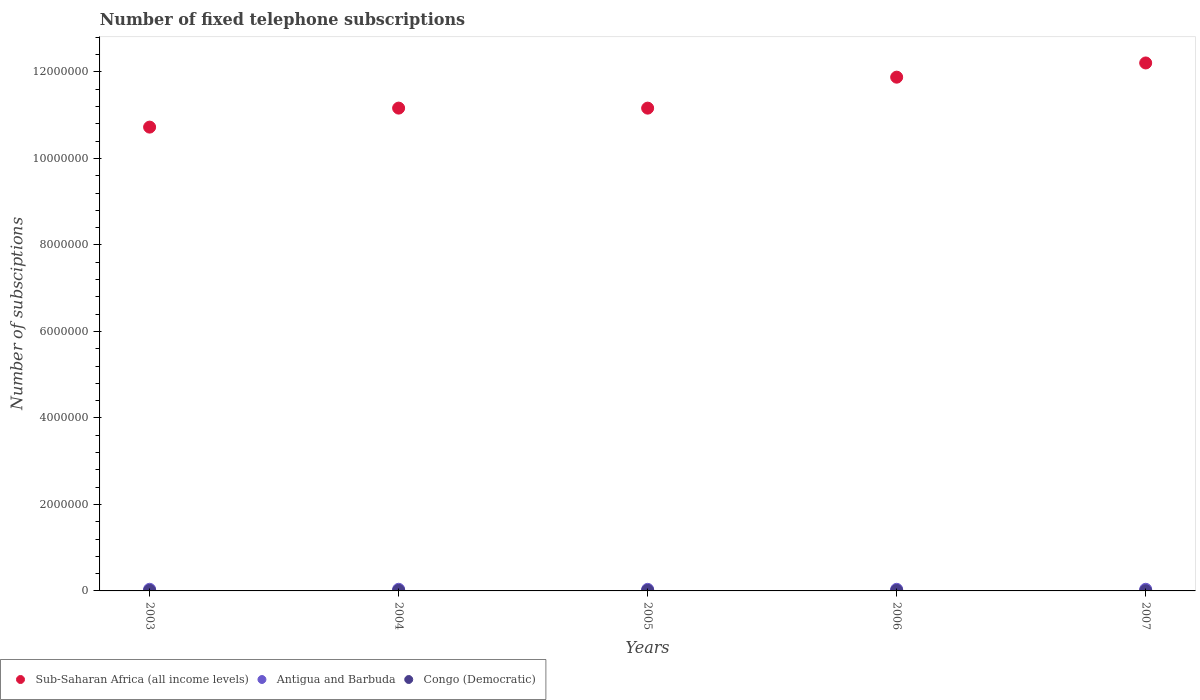How many different coloured dotlines are there?
Keep it short and to the point. 3. What is the number of fixed telephone subscriptions in Sub-Saharan Africa (all income levels) in 2006?
Keep it short and to the point. 1.19e+07. Across all years, what is the maximum number of fixed telephone subscriptions in Antigua and Barbuda?
Provide a short and direct response. 3.80e+04. Across all years, what is the minimum number of fixed telephone subscriptions in Congo (Democratic)?
Give a very brief answer. 3500. In which year was the number of fixed telephone subscriptions in Antigua and Barbuda maximum?
Give a very brief answer. 2003. In which year was the number of fixed telephone subscriptions in Antigua and Barbuda minimum?
Provide a short and direct response. 2005. What is the total number of fixed telephone subscriptions in Antigua and Barbuda in the graph?
Ensure brevity in your answer.  1.88e+05. What is the difference between the number of fixed telephone subscriptions in Antigua and Barbuda in 2006 and the number of fixed telephone subscriptions in Congo (Democratic) in 2007?
Your answer should be compact. 3.40e+04. What is the average number of fixed telephone subscriptions in Sub-Saharan Africa (all income levels) per year?
Make the answer very short. 1.14e+07. In the year 2006, what is the difference between the number of fixed telephone subscriptions in Antigua and Barbuda and number of fixed telephone subscriptions in Congo (Democratic)?
Your answer should be very brief. 2.78e+04. In how many years, is the number of fixed telephone subscriptions in Congo (Democratic) greater than 3200000?
Provide a succinct answer. 0. What is the ratio of the number of fixed telephone subscriptions in Sub-Saharan Africa (all income levels) in 2003 to that in 2005?
Ensure brevity in your answer.  0.96. Is the difference between the number of fixed telephone subscriptions in Antigua and Barbuda in 2004 and 2005 greater than the difference between the number of fixed telephone subscriptions in Congo (Democratic) in 2004 and 2005?
Offer a very short reply. Yes. What is the difference between the highest and the lowest number of fixed telephone subscriptions in Antigua and Barbuda?
Give a very brief answer. 1520. In how many years, is the number of fixed telephone subscriptions in Antigua and Barbuda greater than the average number of fixed telephone subscriptions in Antigua and Barbuda taken over all years?
Your answer should be very brief. 3. Does the number of fixed telephone subscriptions in Sub-Saharan Africa (all income levels) monotonically increase over the years?
Provide a succinct answer. No. Is the number of fixed telephone subscriptions in Sub-Saharan Africa (all income levels) strictly greater than the number of fixed telephone subscriptions in Antigua and Barbuda over the years?
Make the answer very short. Yes. How many dotlines are there?
Your response must be concise. 3. Are the values on the major ticks of Y-axis written in scientific E-notation?
Your answer should be compact. No. Does the graph contain any zero values?
Provide a succinct answer. No. Where does the legend appear in the graph?
Your answer should be very brief. Bottom left. How are the legend labels stacked?
Your answer should be compact. Horizontal. What is the title of the graph?
Provide a succinct answer. Number of fixed telephone subscriptions. Does "United Kingdom" appear as one of the legend labels in the graph?
Give a very brief answer. No. What is the label or title of the Y-axis?
Ensure brevity in your answer.  Number of subsciptions. What is the Number of subsciptions in Sub-Saharan Africa (all income levels) in 2003?
Provide a succinct answer. 1.07e+07. What is the Number of subsciptions of Antigua and Barbuda in 2003?
Offer a very short reply. 3.80e+04. What is the Number of subsciptions in Congo (Democratic) in 2003?
Make the answer very short. 9733. What is the Number of subsciptions of Sub-Saharan Africa (all income levels) in 2004?
Keep it short and to the point. 1.12e+07. What is the Number of subsciptions in Antigua and Barbuda in 2004?
Provide a short and direct response. 3.80e+04. What is the Number of subsciptions of Congo (Democratic) in 2004?
Provide a short and direct response. 1.05e+04. What is the Number of subsciptions of Sub-Saharan Africa (all income levels) in 2005?
Provide a short and direct response. 1.12e+07. What is the Number of subsciptions of Antigua and Barbuda in 2005?
Ensure brevity in your answer.  3.65e+04. What is the Number of subsciptions in Congo (Democratic) in 2005?
Provide a short and direct response. 1.06e+04. What is the Number of subsciptions of Sub-Saharan Africa (all income levels) in 2006?
Make the answer very short. 1.19e+07. What is the Number of subsciptions of Antigua and Barbuda in 2006?
Provide a short and direct response. 3.75e+04. What is the Number of subsciptions in Congo (Democratic) in 2006?
Make the answer very short. 9700. What is the Number of subsciptions of Sub-Saharan Africa (all income levels) in 2007?
Offer a very short reply. 1.22e+07. What is the Number of subsciptions of Antigua and Barbuda in 2007?
Provide a short and direct response. 3.79e+04. What is the Number of subsciptions in Congo (Democratic) in 2007?
Make the answer very short. 3500. Across all years, what is the maximum Number of subsciptions in Sub-Saharan Africa (all income levels)?
Provide a succinct answer. 1.22e+07. Across all years, what is the maximum Number of subsciptions of Antigua and Barbuda?
Provide a succinct answer. 3.80e+04. Across all years, what is the maximum Number of subsciptions in Congo (Democratic)?
Provide a succinct answer. 1.06e+04. Across all years, what is the minimum Number of subsciptions in Sub-Saharan Africa (all income levels)?
Offer a terse response. 1.07e+07. Across all years, what is the minimum Number of subsciptions of Antigua and Barbuda?
Give a very brief answer. 3.65e+04. Across all years, what is the minimum Number of subsciptions in Congo (Democratic)?
Your answer should be very brief. 3500. What is the total Number of subsciptions of Sub-Saharan Africa (all income levels) in the graph?
Give a very brief answer. 5.71e+07. What is the total Number of subsciptions of Antigua and Barbuda in the graph?
Your response must be concise. 1.88e+05. What is the total Number of subsciptions in Congo (Democratic) in the graph?
Provide a succinct answer. 4.40e+04. What is the difference between the Number of subsciptions of Sub-Saharan Africa (all income levels) in 2003 and that in 2004?
Make the answer very short. -4.39e+05. What is the difference between the Number of subsciptions in Congo (Democratic) in 2003 and that in 2004?
Keep it short and to the point. -791. What is the difference between the Number of subsciptions in Sub-Saharan Africa (all income levels) in 2003 and that in 2005?
Offer a very short reply. -4.39e+05. What is the difference between the Number of subsciptions of Antigua and Barbuda in 2003 and that in 2005?
Your answer should be compact. 1520. What is the difference between the Number of subsciptions of Congo (Democratic) in 2003 and that in 2005?
Give a very brief answer. -846. What is the difference between the Number of subsciptions in Sub-Saharan Africa (all income levels) in 2003 and that in 2006?
Give a very brief answer. -1.15e+06. What is the difference between the Number of subsciptions of Congo (Democratic) in 2003 and that in 2006?
Your answer should be compact. 33. What is the difference between the Number of subsciptions of Sub-Saharan Africa (all income levels) in 2003 and that in 2007?
Offer a very short reply. -1.48e+06. What is the difference between the Number of subsciptions in Congo (Democratic) in 2003 and that in 2007?
Provide a short and direct response. 6233. What is the difference between the Number of subsciptions in Sub-Saharan Africa (all income levels) in 2004 and that in 2005?
Your answer should be compact. 614. What is the difference between the Number of subsciptions of Antigua and Barbuda in 2004 and that in 2005?
Your response must be concise. 1520. What is the difference between the Number of subsciptions of Congo (Democratic) in 2004 and that in 2005?
Make the answer very short. -55. What is the difference between the Number of subsciptions of Sub-Saharan Africa (all income levels) in 2004 and that in 2006?
Provide a succinct answer. -7.15e+05. What is the difference between the Number of subsciptions of Congo (Democratic) in 2004 and that in 2006?
Give a very brief answer. 824. What is the difference between the Number of subsciptions of Sub-Saharan Africa (all income levels) in 2004 and that in 2007?
Make the answer very short. -1.04e+06. What is the difference between the Number of subsciptions of Antigua and Barbuda in 2004 and that in 2007?
Your response must be concise. 100. What is the difference between the Number of subsciptions in Congo (Democratic) in 2004 and that in 2007?
Ensure brevity in your answer.  7024. What is the difference between the Number of subsciptions of Sub-Saharan Africa (all income levels) in 2005 and that in 2006?
Your answer should be very brief. -7.16e+05. What is the difference between the Number of subsciptions of Antigua and Barbuda in 2005 and that in 2006?
Give a very brief answer. -1020. What is the difference between the Number of subsciptions in Congo (Democratic) in 2005 and that in 2006?
Your response must be concise. 879. What is the difference between the Number of subsciptions in Sub-Saharan Africa (all income levels) in 2005 and that in 2007?
Give a very brief answer. -1.04e+06. What is the difference between the Number of subsciptions in Antigua and Barbuda in 2005 and that in 2007?
Provide a succinct answer. -1420. What is the difference between the Number of subsciptions of Congo (Democratic) in 2005 and that in 2007?
Provide a succinct answer. 7079. What is the difference between the Number of subsciptions in Sub-Saharan Africa (all income levels) in 2006 and that in 2007?
Give a very brief answer. -3.28e+05. What is the difference between the Number of subsciptions in Antigua and Barbuda in 2006 and that in 2007?
Ensure brevity in your answer.  -400. What is the difference between the Number of subsciptions of Congo (Democratic) in 2006 and that in 2007?
Offer a terse response. 6200. What is the difference between the Number of subsciptions of Sub-Saharan Africa (all income levels) in 2003 and the Number of subsciptions of Antigua and Barbuda in 2004?
Keep it short and to the point. 1.07e+07. What is the difference between the Number of subsciptions in Sub-Saharan Africa (all income levels) in 2003 and the Number of subsciptions in Congo (Democratic) in 2004?
Give a very brief answer. 1.07e+07. What is the difference between the Number of subsciptions in Antigua and Barbuda in 2003 and the Number of subsciptions in Congo (Democratic) in 2004?
Keep it short and to the point. 2.75e+04. What is the difference between the Number of subsciptions in Sub-Saharan Africa (all income levels) in 2003 and the Number of subsciptions in Antigua and Barbuda in 2005?
Keep it short and to the point. 1.07e+07. What is the difference between the Number of subsciptions in Sub-Saharan Africa (all income levels) in 2003 and the Number of subsciptions in Congo (Democratic) in 2005?
Give a very brief answer. 1.07e+07. What is the difference between the Number of subsciptions in Antigua and Barbuda in 2003 and the Number of subsciptions in Congo (Democratic) in 2005?
Offer a very short reply. 2.74e+04. What is the difference between the Number of subsciptions in Sub-Saharan Africa (all income levels) in 2003 and the Number of subsciptions in Antigua and Barbuda in 2006?
Give a very brief answer. 1.07e+07. What is the difference between the Number of subsciptions in Sub-Saharan Africa (all income levels) in 2003 and the Number of subsciptions in Congo (Democratic) in 2006?
Your answer should be compact. 1.07e+07. What is the difference between the Number of subsciptions of Antigua and Barbuda in 2003 and the Number of subsciptions of Congo (Democratic) in 2006?
Offer a terse response. 2.83e+04. What is the difference between the Number of subsciptions of Sub-Saharan Africa (all income levels) in 2003 and the Number of subsciptions of Antigua and Barbuda in 2007?
Offer a very short reply. 1.07e+07. What is the difference between the Number of subsciptions in Sub-Saharan Africa (all income levels) in 2003 and the Number of subsciptions in Congo (Democratic) in 2007?
Your response must be concise. 1.07e+07. What is the difference between the Number of subsciptions of Antigua and Barbuda in 2003 and the Number of subsciptions of Congo (Democratic) in 2007?
Your answer should be compact. 3.45e+04. What is the difference between the Number of subsciptions of Sub-Saharan Africa (all income levels) in 2004 and the Number of subsciptions of Antigua and Barbuda in 2005?
Offer a terse response. 1.11e+07. What is the difference between the Number of subsciptions of Sub-Saharan Africa (all income levels) in 2004 and the Number of subsciptions of Congo (Democratic) in 2005?
Offer a terse response. 1.12e+07. What is the difference between the Number of subsciptions in Antigua and Barbuda in 2004 and the Number of subsciptions in Congo (Democratic) in 2005?
Offer a terse response. 2.74e+04. What is the difference between the Number of subsciptions in Sub-Saharan Africa (all income levels) in 2004 and the Number of subsciptions in Antigua and Barbuda in 2006?
Offer a very short reply. 1.11e+07. What is the difference between the Number of subsciptions of Sub-Saharan Africa (all income levels) in 2004 and the Number of subsciptions of Congo (Democratic) in 2006?
Offer a very short reply. 1.12e+07. What is the difference between the Number of subsciptions in Antigua and Barbuda in 2004 and the Number of subsciptions in Congo (Democratic) in 2006?
Give a very brief answer. 2.83e+04. What is the difference between the Number of subsciptions of Sub-Saharan Africa (all income levels) in 2004 and the Number of subsciptions of Antigua and Barbuda in 2007?
Provide a succinct answer. 1.11e+07. What is the difference between the Number of subsciptions of Sub-Saharan Africa (all income levels) in 2004 and the Number of subsciptions of Congo (Democratic) in 2007?
Give a very brief answer. 1.12e+07. What is the difference between the Number of subsciptions of Antigua and Barbuda in 2004 and the Number of subsciptions of Congo (Democratic) in 2007?
Your answer should be very brief. 3.45e+04. What is the difference between the Number of subsciptions of Sub-Saharan Africa (all income levels) in 2005 and the Number of subsciptions of Antigua and Barbuda in 2006?
Your answer should be very brief. 1.11e+07. What is the difference between the Number of subsciptions in Sub-Saharan Africa (all income levels) in 2005 and the Number of subsciptions in Congo (Democratic) in 2006?
Ensure brevity in your answer.  1.12e+07. What is the difference between the Number of subsciptions in Antigua and Barbuda in 2005 and the Number of subsciptions in Congo (Democratic) in 2006?
Your answer should be very brief. 2.68e+04. What is the difference between the Number of subsciptions of Sub-Saharan Africa (all income levels) in 2005 and the Number of subsciptions of Antigua and Barbuda in 2007?
Offer a very short reply. 1.11e+07. What is the difference between the Number of subsciptions of Sub-Saharan Africa (all income levels) in 2005 and the Number of subsciptions of Congo (Democratic) in 2007?
Provide a short and direct response. 1.12e+07. What is the difference between the Number of subsciptions in Antigua and Barbuda in 2005 and the Number of subsciptions in Congo (Democratic) in 2007?
Offer a very short reply. 3.30e+04. What is the difference between the Number of subsciptions of Sub-Saharan Africa (all income levels) in 2006 and the Number of subsciptions of Antigua and Barbuda in 2007?
Ensure brevity in your answer.  1.18e+07. What is the difference between the Number of subsciptions of Sub-Saharan Africa (all income levels) in 2006 and the Number of subsciptions of Congo (Democratic) in 2007?
Provide a short and direct response. 1.19e+07. What is the difference between the Number of subsciptions in Antigua and Barbuda in 2006 and the Number of subsciptions in Congo (Democratic) in 2007?
Your response must be concise. 3.40e+04. What is the average Number of subsciptions in Sub-Saharan Africa (all income levels) per year?
Offer a very short reply. 1.14e+07. What is the average Number of subsciptions of Antigua and Barbuda per year?
Ensure brevity in your answer.  3.76e+04. What is the average Number of subsciptions of Congo (Democratic) per year?
Ensure brevity in your answer.  8807.2. In the year 2003, what is the difference between the Number of subsciptions of Sub-Saharan Africa (all income levels) and Number of subsciptions of Antigua and Barbuda?
Offer a very short reply. 1.07e+07. In the year 2003, what is the difference between the Number of subsciptions of Sub-Saharan Africa (all income levels) and Number of subsciptions of Congo (Democratic)?
Offer a very short reply. 1.07e+07. In the year 2003, what is the difference between the Number of subsciptions of Antigua and Barbuda and Number of subsciptions of Congo (Democratic)?
Provide a succinct answer. 2.83e+04. In the year 2004, what is the difference between the Number of subsciptions in Sub-Saharan Africa (all income levels) and Number of subsciptions in Antigua and Barbuda?
Your answer should be very brief. 1.11e+07. In the year 2004, what is the difference between the Number of subsciptions of Sub-Saharan Africa (all income levels) and Number of subsciptions of Congo (Democratic)?
Make the answer very short. 1.12e+07. In the year 2004, what is the difference between the Number of subsciptions in Antigua and Barbuda and Number of subsciptions in Congo (Democratic)?
Provide a short and direct response. 2.75e+04. In the year 2005, what is the difference between the Number of subsciptions of Sub-Saharan Africa (all income levels) and Number of subsciptions of Antigua and Barbuda?
Keep it short and to the point. 1.11e+07. In the year 2005, what is the difference between the Number of subsciptions in Sub-Saharan Africa (all income levels) and Number of subsciptions in Congo (Democratic)?
Keep it short and to the point. 1.12e+07. In the year 2005, what is the difference between the Number of subsciptions in Antigua and Barbuda and Number of subsciptions in Congo (Democratic)?
Your response must be concise. 2.59e+04. In the year 2006, what is the difference between the Number of subsciptions in Sub-Saharan Africa (all income levels) and Number of subsciptions in Antigua and Barbuda?
Give a very brief answer. 1.18e+07. In the year 2006, what is the difference between the Number of subsciptions of Sub-Saharan Africa (all income levels) and Number of subsciptions of Congo (Democratic)?
Keep it short and to the point. 1.19e+07. In the year 2006, what is the difference between the Number of subsciptions of Antigua and Barbuda and Number of subsciptions of Congo (Democratic)?
Your answer should be very brief. 2.78e+04. In the year 2007, what is the difference between the Number of subsciptions in Sub-Saharan Africa (all income levels) and Number of subsciptions in Antigua and Barbuda?
Provide a succinct answer. 1.22e+07. In the year 2007, what is the difference between the Number of subsciptions in Sub-Saharan Africa (all income levels) and Number of subsciptions in Congo (Democratic)?
Offer a terse response. 1.22e+07. In the year 2007, what is the difference between the Number of subsciptions of Antigua and Barbuda and Number of subsciptions of Congo (Democratic)?
Make the answer very short. 3.44e+04. What is the ratio of the Number of subsciptions of Sub-Saharan Africa (all income levels) in 2003 to that in 2004?
Provide a short and direct response. 0.96. What is the ratio of the Number of subsciptions of Antigua and Barbuda in 2003 to that in 2004?
Give a very brief answer. 1. What is the ratio of the Number of subsciptions of Congo (Democratic) in 2003 to that in 2004?
Provide a succinct answer. 0.92. What is the ratio of the Number of subsciptions in Sub-Saharan Africa (all income levels) in 2003 to that in 2005?
Your answer should be compact. 0.96. What is the ratio of the Number of subsciptions in Antigua and Barbuda in 2003 to that in 2005?
Give a very brief answer. 1.04. What is the ratio of the Number of subsciptions in Congo (Democratic) in 2003 to that in 2005?
Give a very brief answer. 0.92. What is the ratio of the Number of subsciptions of Sub-Saharan Africa (all income levels) in 2003 to that in 2006?
Give a very brief answer. 0.9. What is the ratio of the Number of subsciptions of Antigua and Barbuda in 2003 to that in 2006?
Offer a very short reply. 1.01. What is the ratio of the Number of subsciptions in Congo (Democratic) in 2003 to that in 2006?
Offer a very short reply. 1. What is the ratio of the Number of subsciptions of Sub-Saharan Africa (all income levels) in 2003 to that in 2007?
Your answer should be compact. 0.88. What is the ratio of the Number of subsciptions in Congo (Democratic) in 2003 to that in 2007?
Offer a terse response. 2.78. What is the ratio of the Number of subsciptions of Sub-Saharan Africa (all income levels) in 2004 to that in 2005?
Your response must be concise. 1. What is the ratio of the Number of subsciptions in Antigua and Barbuda in 2004 to that in 2005?
Your answer should be compact. 1.04. What is the ratio of the Number of subsciptions in Sub-Saharan Africa (all income levels) in 2004 to that in 2006?
Offer a terse response. 0.94. What is the ratio of the Number of subsciptions in Antigua and Barbuda in 2004 to that in 2006?
Provide a succinct answer. 1.01. What is the ratio of the Number of subsciptions in Congo (Democratic) in 2004 to that in 2006?
Offer a terse response. 1.08. What is the ratio of the Number of subsciptions in Sub-Saharan Africa (all income levels) in 2004 to that in 2007?
Your answer should be compact. 0.91. What is the ratio of the Number of subsciptions in Antigua and Barbuda in 2004 to that in 2007?
Your response must be concise. 1. What is the ratio of the Number of subsciptions in Congo (Democratic) in 2004 to that in 2007?
Provide a succinct answer. 3.01. What is the ratio of the Number of subsciptions in Sub-Saharan Africa (all income levels) in 2005 to that in 2006?
Provide a succinct answer. 0.94. What is the ratio of the Number of subsciptions in Antigua and Barbuda in 2005 to that in 2006?
Offer a terse response. 0.97. What is the ratio of the Number of subsciptions of Congo (Democratic) in 2005 to that in 2006?
Offer a very short reply. 1.09. What is the ratio of the Number of subsciptions in Sub-Saharan Africa (all income levels) in 2005 to that in 2007?
Your answer should be compact. 0.91. What is the ratio of the Number of subsciptions in Antigua and Barbuda in 2005 to that in 2007?
Give a very brief answer. 0.96. What is the ratio of the Number of subsciptions of Congo (Democratic) in 2005 to that in 2007?
Provide a short and direct response. 3.02. What is the ratio of the Number of subsciptions in Sub-Saharan Africa (all income levels) in 2006 to that in 2007?
Your response must be concise. 0.97. What is the ratio of the Number of subsciptions of Antigua and Barbuda in 2006 to that in 2007?
Give a very brief answer. 0.99. What is the ratio of the Number of subsciptions of Congo (Democratic) in 2006 to that in 2007?
Ensure brevity in your answer.  2.77. What is the difference between the highest and the second highest Number of subsciptions of Sub-Saharan Africa (all income levels)?
Keep it short and to the point. 3.28e+05. What is the difference between the highest and the second highest Number of subsciptions of Antigua and Barbuda?
Provide a succinct answer. 0. What is the difference between the highest and the lowest Number of subsciptions of Sub-Saharan Africa (all income levels)?
Offer a terse response. 1.48e+06. What is the difference between the highest and the lowest Number of subsciptions in Antigua and Barbuda?
Provide a succinct answer. 1520. What is the difference between the highest and the lowest Number of subsciptions of Congo (Democratic)?
Provide a short and direct response. 7079. 